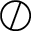Convert formula to latex. <formula><loc_0><loc_0><loc_500><loc_500>\oslash</formula> 